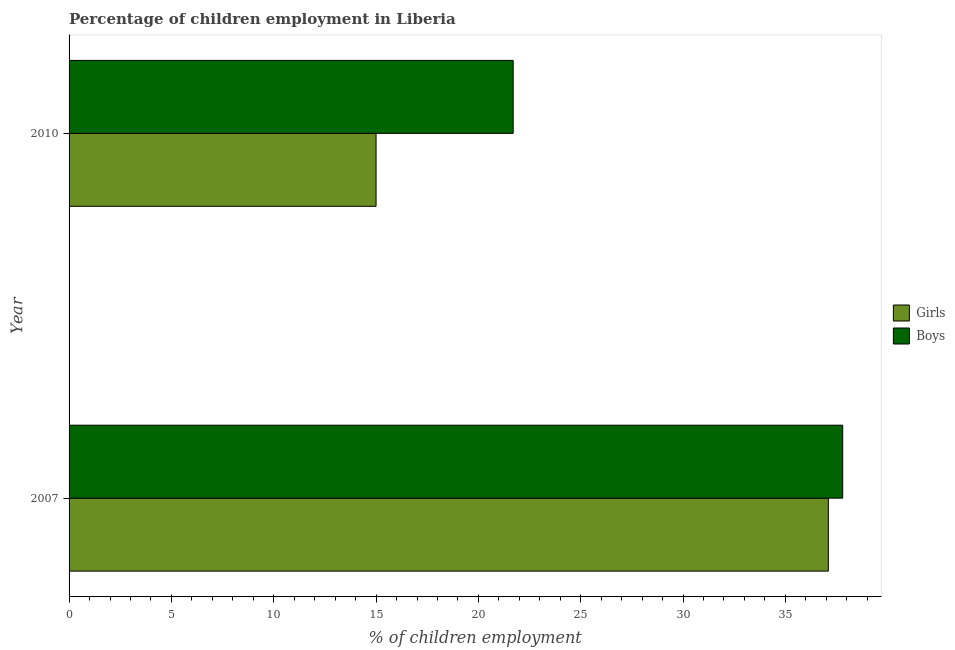How many different coloured bars are there?
Make the answer very short. 2. How many bars are there on the 1st tick from the top?
Give a very brief answer. 2. How many bars are there on the 2nd tick from the bottom?
Your answer should be compact. 2. In how many cases, is the number of bars for a given year not equal to the number of legend labels?
Provide a succinct answer. 0. Across all years, what is the maximum percentage of employed girls?
Provide a succinct answer. 37.1. Across all years, what is the minimum percentage of employed girls?
Provide a succinct answer. 15. What is the total percentage of employed girls in the graph?
Ensure brevity in your answer.  52.1. What is the difference between the percentage of employed girls in 2010 and the percentage of employed boys in 2007?
Make the answer very short. -22.8. What is the average percentage of employed girls per year?
Your response must be concise. 26.05. In the year 2010, what is the difference between the percentage of employed boys and percentage of employed girls?
Offer a terse response. 6.7. In how many years, is the percentage of employed girls greater than 9 %?
Offer a terse response. 2. What is the ratio of the percentage of employed girls in 2007 to that in 2010?
Provide a succinct answer. 2.47. Is the difference between the percentage of employed girls in 2007 and 2010 greater than the difference between the percentage of employed boys in 2007 and 2010?
Give a very brief answer. Yes. What does the 1st bar from the top in 2007 represents?
Give a very brief answer. Boys. What does the 2nd bar from the bottom in 2007 represents?
Ensure brevity in your answer.  Boys. How many bars are there?
Make the answer very short. 4. What is the difference between two consecutive major ticks on the X-axis?
Make the answer very short. 5. Are the values on the major ticks of X-axis written in scientific E-notation?
Your answer should be very brief. No. Does the graph contain any zero values?
Provide a succinct answer. No. Does the graph contain grids?
Make the answer very short. No. Where does the legend appear in the graph?
Ensure brevity in your answer.  Center right. What is the title of the graph?
Give a very brief answer. Percentage of children employment in Liberia. Does "Primary completion rate" appear as one of the legend labels in the graph?
Give a very brief answer. No. What is the label or title of the X-axis?
Your answer should be compact. % of children employment. What is the label or title of the Y-axis?
Keep it short and to the point. Year. What is the % of children employment of Girls in 2007?
Offer a terse response. 37.1. What is the % of children employment in Boys in 2007?
Ensure brevity in your answer.  37.8. What is the % of children employment of Girls in 2010?
Ensure brevity in your answer.  15. What is the % of children employment of Boys in 2010?
Offer a terse response. 21.7. Across all years, what is the maximum % of children employment of Girls?
Offer a very short reply. 37.1. Across all years, what is the maximum % of children employment in Boys?
Provide a succinct answer. 37.8. Across all years, what is the minimum % of children employment in Girls?
Your response must be concise. 15. Across all years, what is the minimum % of children employment in Boys?
Your answer should be very brief. 21.7. What is the total % of children employment in Girls in the graph?
Your answer should be very brief. 52.1. What is the total % of children employment in Boys in the graph?
Offer a very short reply. 59.5. What is the difference between the % of children employment of Girls in 2007 and that in 2010?
Provide a short and direct response. 22.1. What is the difference between the % of children employment in Girls in 2007 and the % of children employment in Boys in 2010?
Your answer should be very brief. 15.4. What is the average % of children employment in Girls per year?
Your response must be concise. 26.05. What is the average % of children employment in Boys per year?
Your answer should be compact. 29.75. What is the ratio of the % of children employment of Girls in 2007 to that in 2010?
Your answer should be compact. 2.47. What is the ratio of the % of children employment in Boys in 2007 to that in 2010?
Offer a very short reply. 1.74. What is the difference between the highest and the second highest % of children employment in Girls?
Make the answer very short. 22.1. What is the difference between the highest and the lowest % of children employment in Girls?
Your answer should be compact. 22.1. 